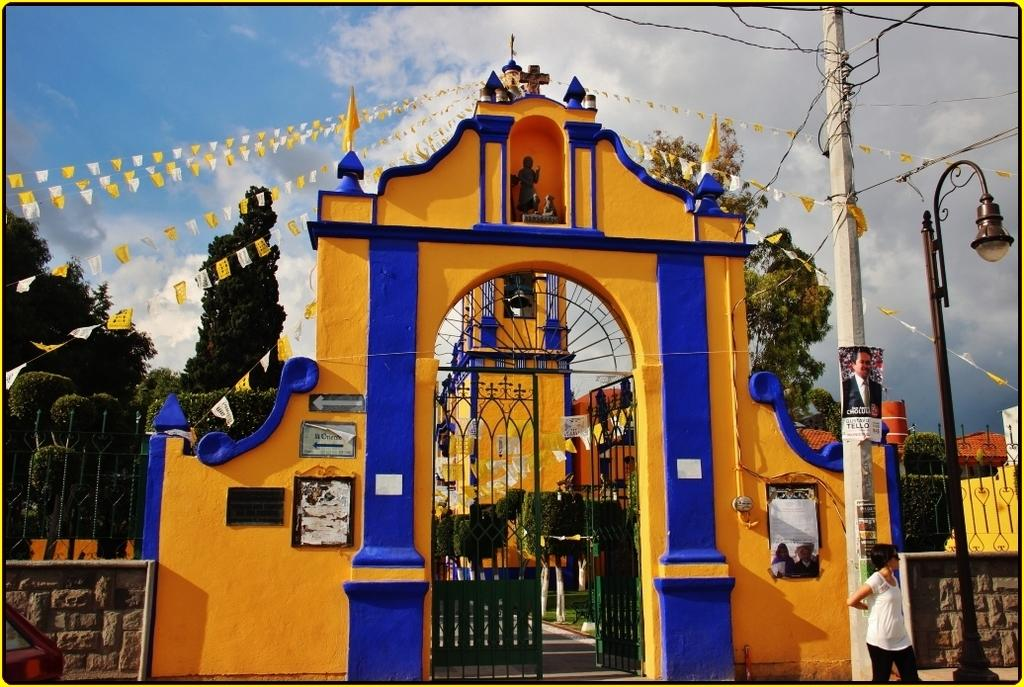What type of structure can be seen in the image? There is a wall and a gate in the image. What other objects are present in the image? There is a pole, a light, and trees in the image. What is the color of the sky in the image? The sky is blue in the image. Are there any weather conditions visible in the image? Yes, there are clouds in the image. What type of feast is being prepared in the image? There is no indication of a feast or any food preparation in the image. Can you tell me where the laborer is working in the image? There is no laborer present in the image. 